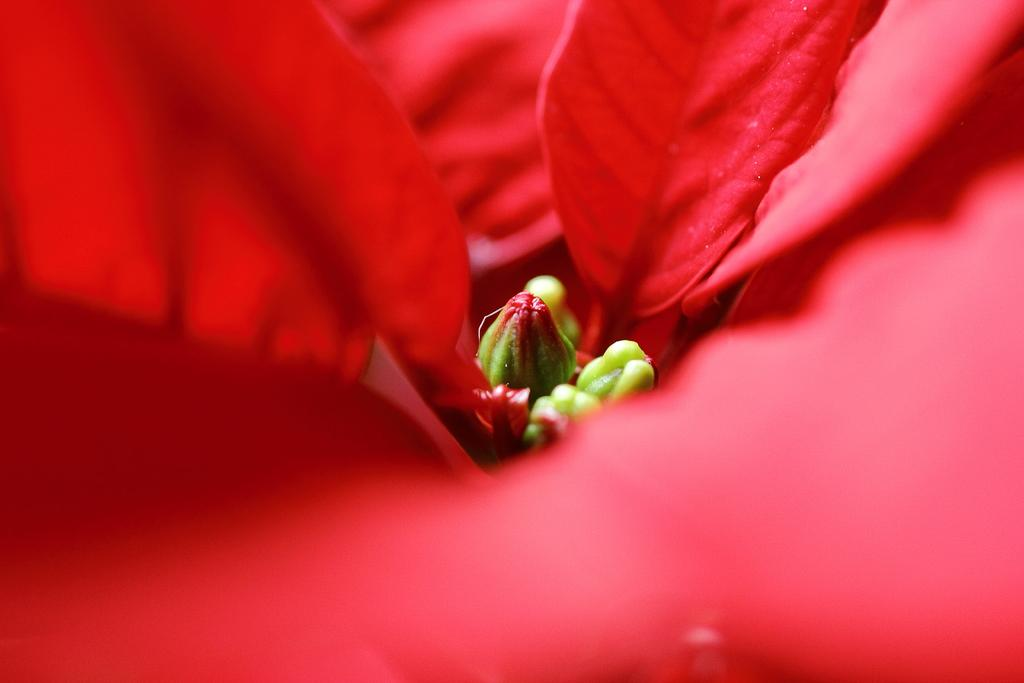What is the main subject in the middle of the image? There is a bird in the middle of the image. What can be seen in terms of color and objects in the image? There are red color petals in the image. What type of bomb can be seen in the image? There is no bomb present in the image; it features a bird and red color petals. What kind of horn is visible in the image? There is no horn present in the image. 